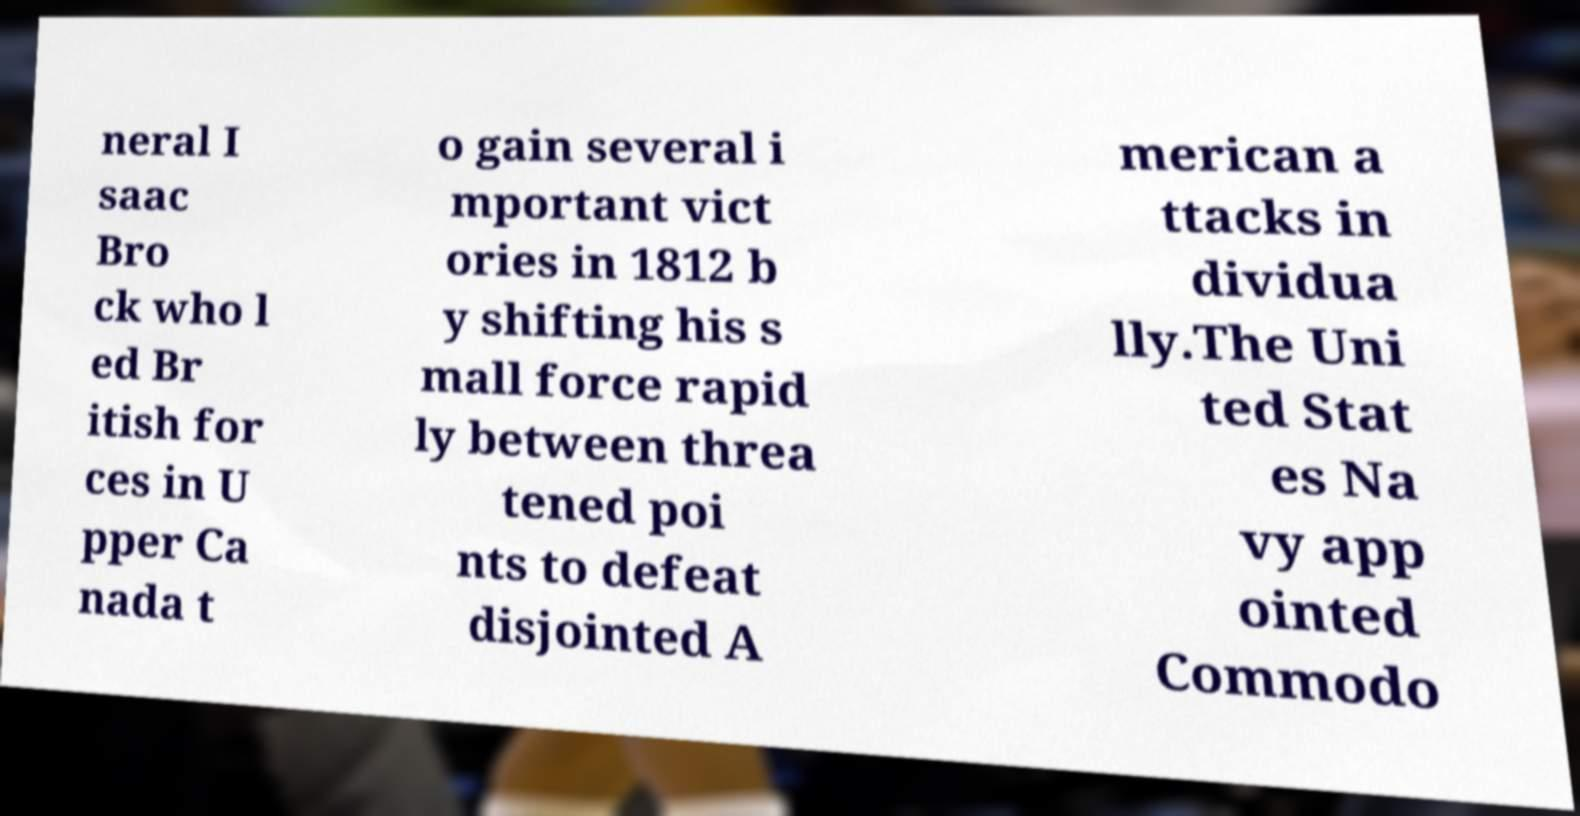Please read and relay the text visible in this image. What does it say? neral I saac Bro ck who l ed Br itish for ces in U pper Ca nada t o gain several i mportant vict ories in 1812 b y shifting his s mall force rapid ly between threa tened poi nts to defeat disjointed A merican a ttacks in dividua lly.The Uni ted Stat es Na vy app ointed Commodo 